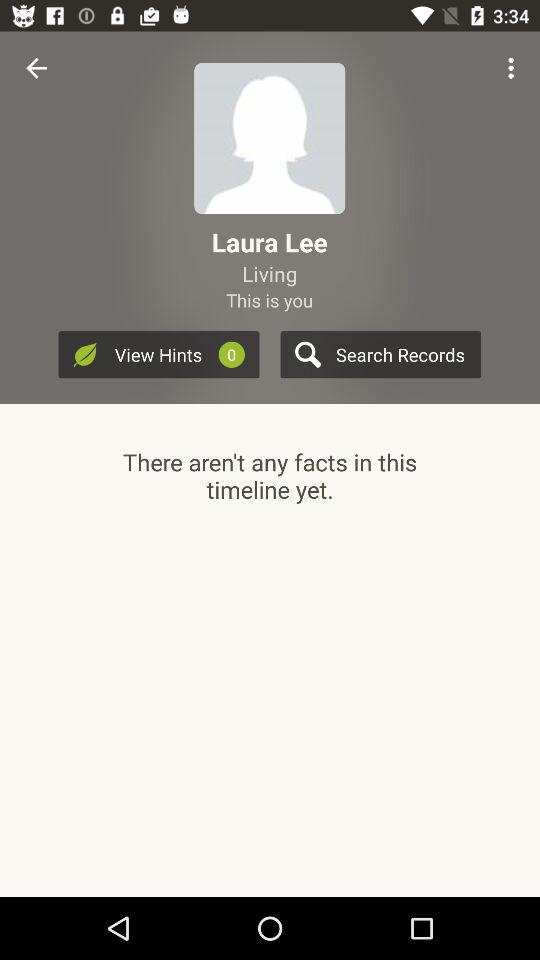How many facts are in this timeline?
Answer the question using a single word or phrase. 0 